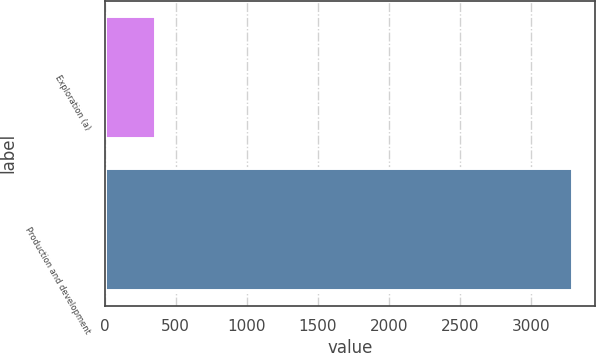<chart> <loc_0><loc_0><loc_500><loc_500><bar_chart><fcel>Exploration (a)<fcel>Production and development<nl><fcel>354<fcel>3292<nl></chart> 